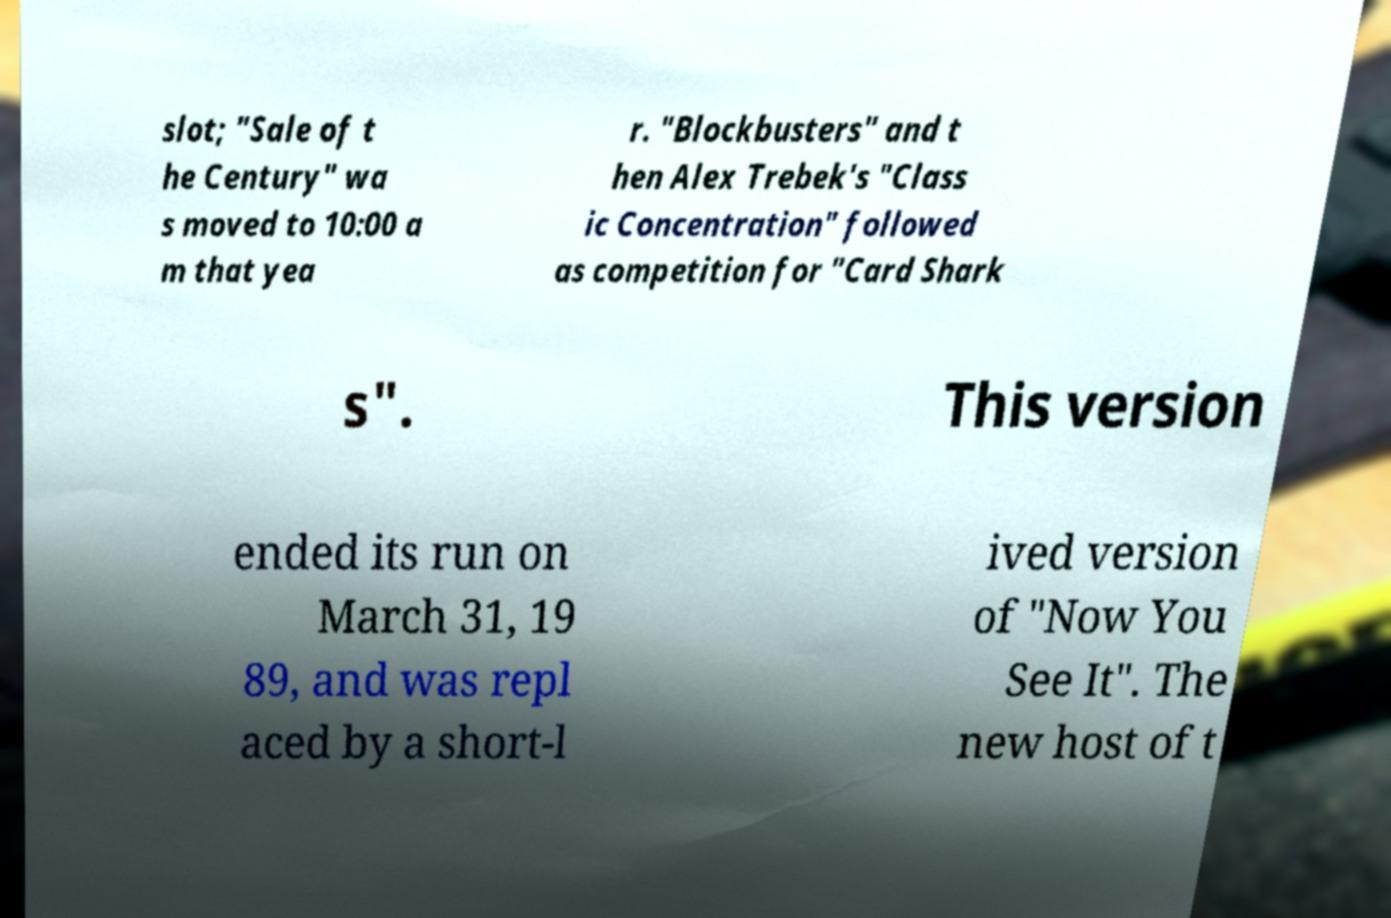What messages or text are displayed in this image? I need them in a readable, typed format. slot; "Sale of t he Century" wa s moved to 10:00 a m that yea r. "Blockbusters" and t hen Alex Trebek's "Class ic Concentration" followed as competition for "Card Shark s". This version ended its run on March 31, 19 89, and was repl aced by a short-l ived version of "Now You See It". The new host of t 